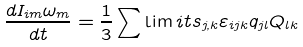Convert formula to latex. <formula><loc_0><loc_0><loc_500><loc_500>\frac { { d { I } _ { i m } \omega _ { m } } } { d t } = \frac { 1 } { 3 } \sum \lim i t s _ { j , k } { \varepsilon _ { i j k } q _ { j l } Q _ { l k } }</formula> 